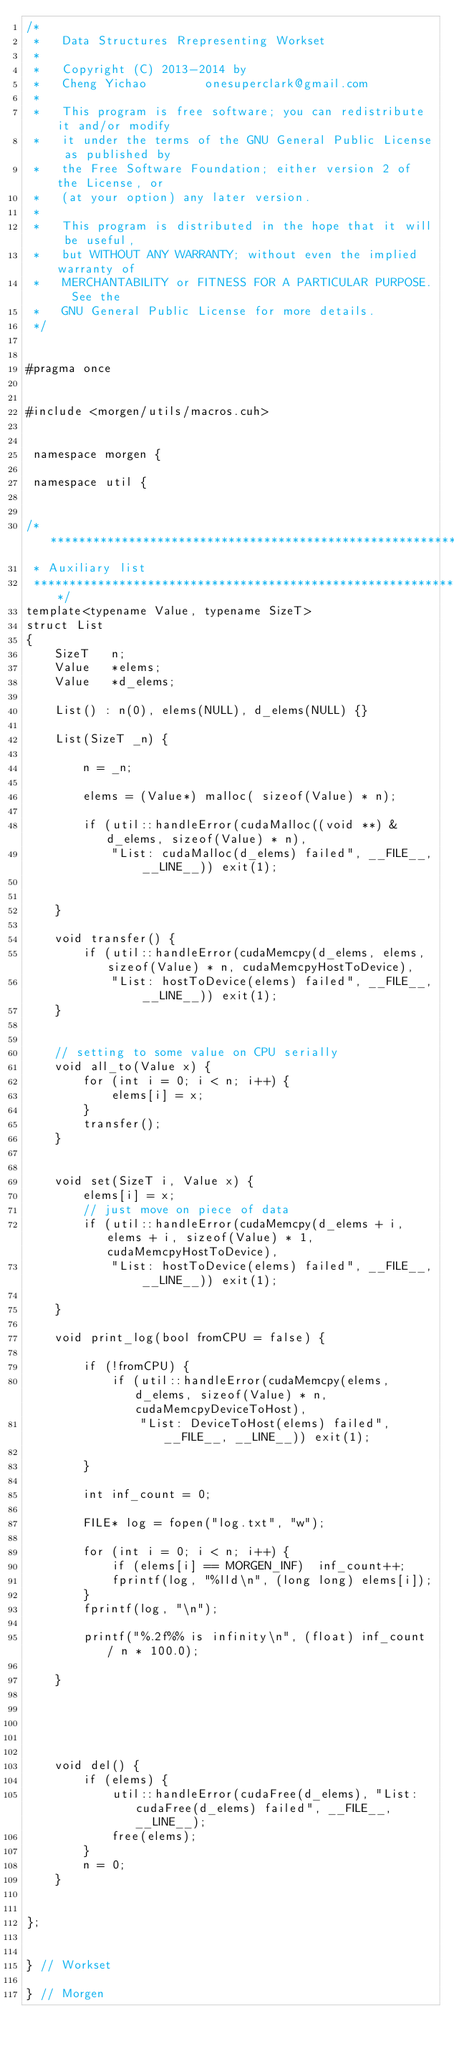<code> <loc_0><loc_0><loc_500><loc_500><_Cuda_>/*
 *   Data Structures Rrepresenting Workset
 *
 *   Copyright (C) 2013-2014 by
 *   Cheng Yichao        onesuperclark@gmail.com
 *
 *   This program is free software; you can redistribute it and/or modify
 *   it under the terms of the GNU General Public License as published by
 *   the Free Software Foundation; either version 2 of the License, or
 *   (at your option) any later version.
 *
 *   This program is distributed in the hope that it will be useful,
 *   but WITHOUT ANY WARRANTY; without even the implied warranty of
 *   MERCHANTABILITY or FITNESS FOR A PARTICULAR PURPOSE.  See the
 *   GNU General Public License for more details.
 */


#pragma once


#include <morgen/utils/macros.cuh>


 namespace morgen {

 namespace util {

 
/******************************************************************************
 * Auxiliary list
 ******************************************************************************/
template<typename Value, typename SizeT>
struct List
{
    SizeT   n;
    Value   *elems;
    Value   *d_elems;

    List() : n(0), elems(NULL), d_elems(NULL) {}

    List(SizeT _n) {

        n = _n;

        elems = (Value*) malloc( sizeof(Value) * n);

        if (util::handleError(cudaMalloc((void **) &d_elems, sizeof(Value) * n),
            "List: cudaMalloc(d_elems) failed", __FILE__, __LINE__)) exit(1);


    }

    void transfer() {
        if (util::handleError(cudaMemcpy(d_elems, elems, sizeof(Value) * n, cudaMemcpyHostToDevice), 
            "List: hostToDevice(elems) failed", __FILE__, __LINE__)) exit(1);
    }


    // setting to some value on CPU serially
    void all_to(Value x) {
        for (int i = 0; i < n; i++) {
            elems[i] = x;
        }
        transfer();
    }


    void set(SizeT i, Value x) {
        elems[i] = x;
        // just move on piece of data
        if (util::handleError(cudaMemcpy(d_elems + i, elems + i, sizeof(Value) * 1, cudaMemcpyHostToDevice), 
            "List: hostToDevice(elems) failed", __FILE__, __LINE__)) exit(1);
    
    }

    void print_log(bool fromCPU = false) {

        if (!fromCPU) {
            if (util::handleError(cudaMemcpy(elems, d_elems, sizeof(Value) * n, cudaMemcpyDeviceToHost), 
                "List: DeviceToHost(elems) failed", __FILE__, __LINE__)) exit(1);

        }
    
        int inf_count = 0;

        FILE* log = fopen("log.txt", "w");

        for (int i = 0; i < n; i++) {
            if (elems[i] == MORGEN_INF)  inf_count++; 
            fprintf(log, "%lld\n", (long long) elems[i]);
        }
        fprintf(log, "\n");

        printf("%.2f%% is infinity\n", (float) inf_count / n * 100.0);

    }





    void del() {
        if (elems) {
            util::handleError(cudaFree(d_elems), "List: cudaFree(d_elems) failed", __FILE__, __LINE__);
            free(elems);
        }
        n = 0;
    }


};


} // Workset

} // Morgen
</code> 